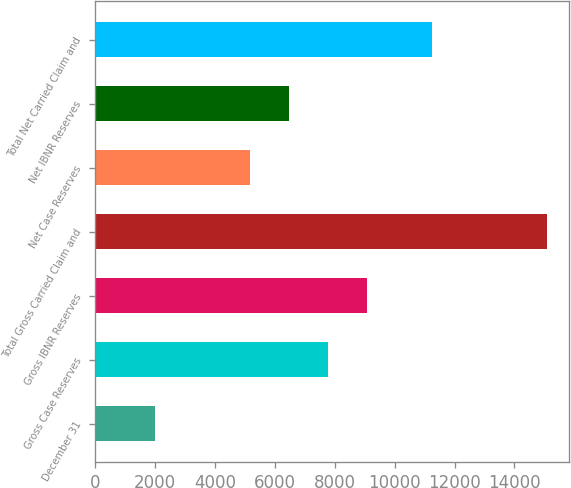Convert chart to OTSL. <chart><loc_0><loc_0><loc_500><loc_500><bar_chart><fcel>December 31<fcel>Gross Case Reserves<fcel>Gross IBNR Reserves<fcel>Total Gross Carried Claim and<fcel>Net Case Reserves<fcel>Net IBNR Reserves<fcel>Total Net Carried Claim and<nl><fcel>2005<fcel>7780.8<fcel>9088.7<fcel>15084<fcel>5165<fcel>6472.9<fcel>11246<nl></chart> 